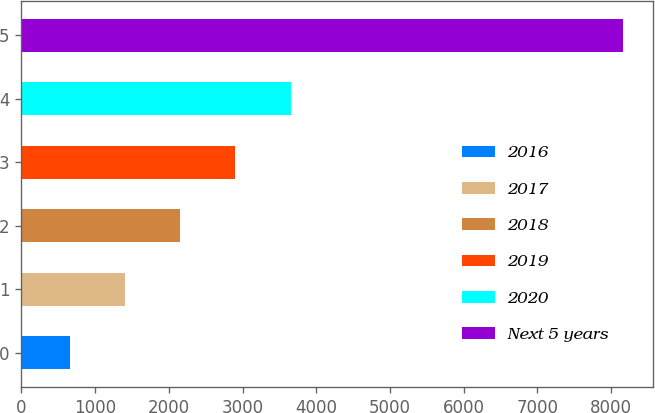<chart> <loc_0><loc_0><loc_500><loc_500><bar_chart><fcel>2016<fcel>2017<fcel>2018<fcel>2019<fcel>2020<fcel>Next 5 years<nl><fcel>654<fcel>1404.3<fcel>2154.6<fcel>2904.9<fcel>3655.2<fcel>8157<nl></chart> 